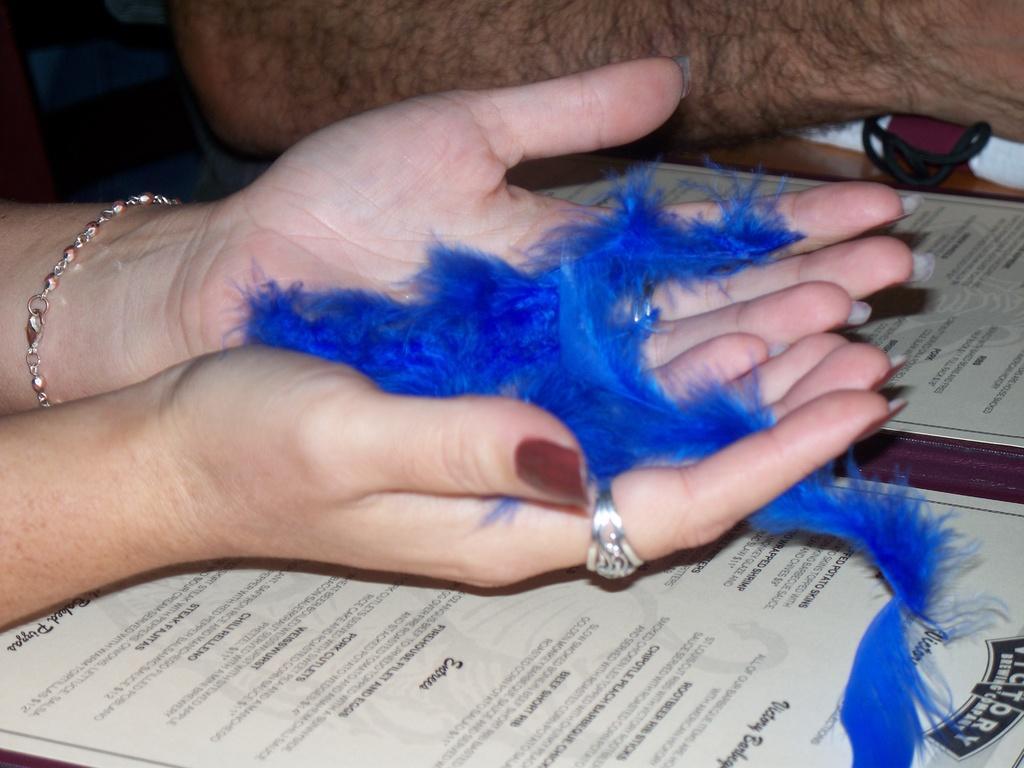Describe this image in one or two sentences. In this picture we can see hands of two persons, they are looking like certificates at the bottom, we can see a ribbon in these hands. 